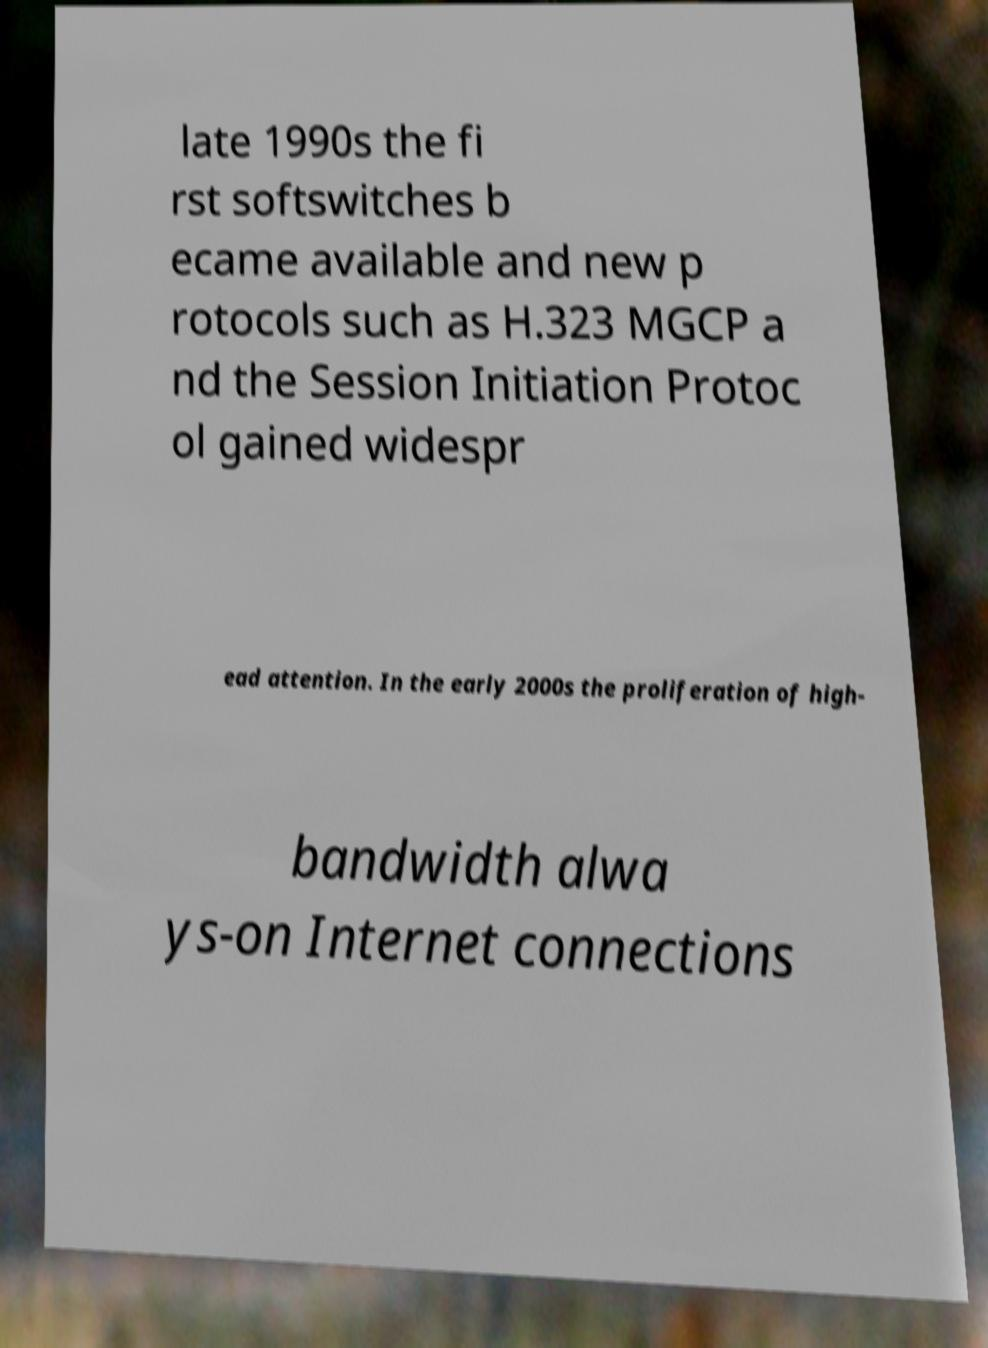Could you extract and type out the text from this image? late 1990s the fi rst softswitches b ecame available and new p rotocols such as H.323 MGCP a nd the Session Initiation Protoc ol gained widespr ead attention. In the early 2000s the proliferation of high- bandwidth alwa ys-on Internet connections 